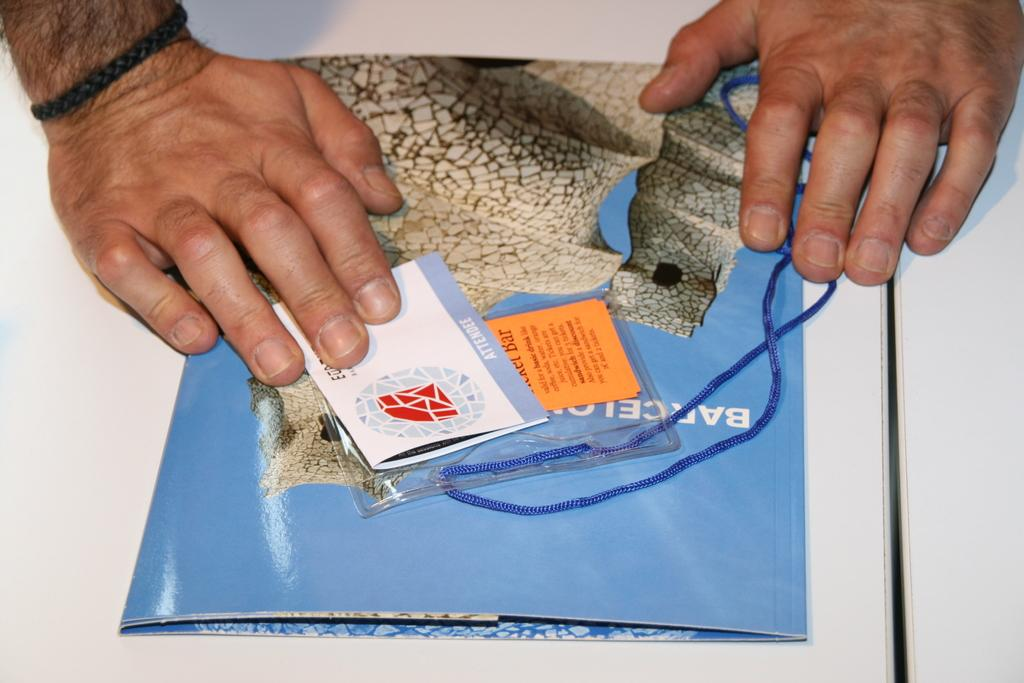What part of a person can be seen in the image? There is a hand of a person on the table. What is the person holding in the image? The person is holding a booklet and a card. What object is placed on the table in the image? There is a thread placed on the table. Can you see a ghost in the image? No, there is no ghost present in the image. 